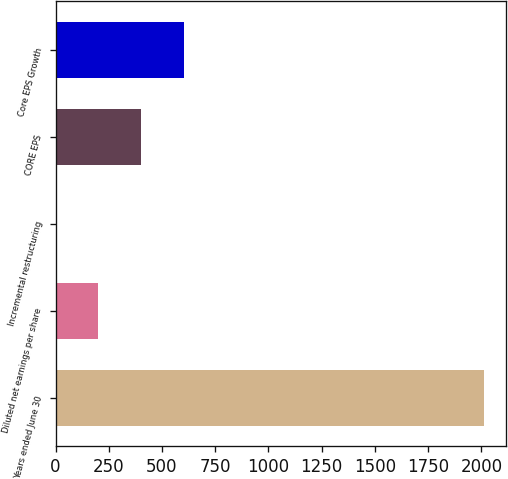Convert chart. <chart><loc_0><loc_0><loc_500><loc_500><bar_chart><fcel>Years ended June 30<fcel>Diluted net earnings per share<fcel>Incremental restructuring<fcel>CORE EPS<fcel>Core EPS Growth<nl><fcel>2014<fcel>201.5<fcel>0.11<fcel>402.89<fcel>604.28<nl></chart> 